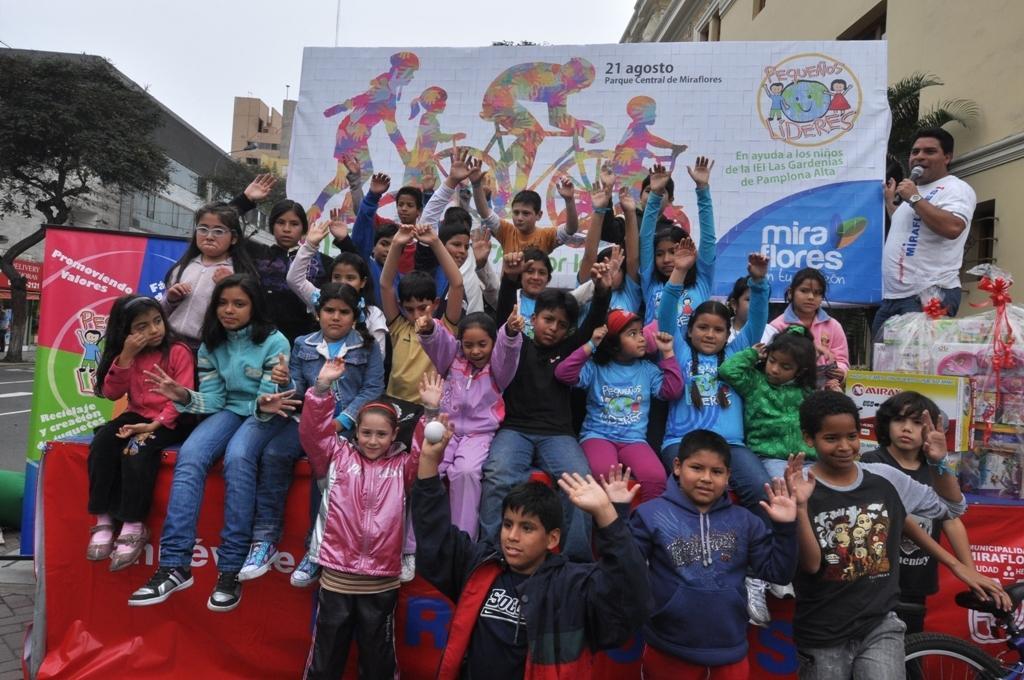In one or two sentences, can you explain what this image depicts? In this picture we can see some kids are sitting and some kids are standing. A man in the white t shirt is holding a microphone in hand. On the right side of the kids there is a bicycle. Behind the kids there is a board, banner and some objects. Behind the board there are building, trees and the sky. 